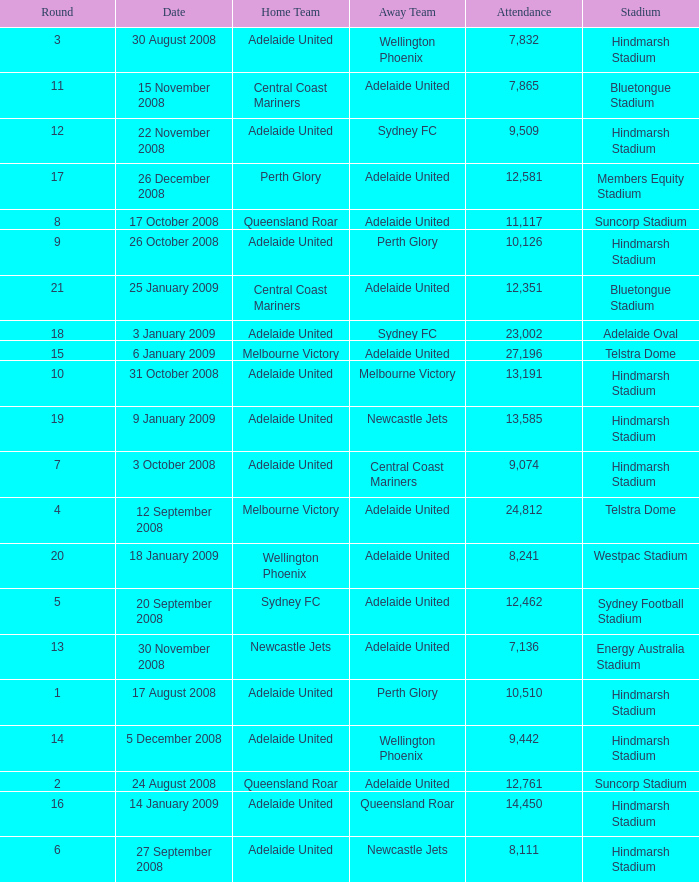What is the round when 11,117 people attended the game on 26 October 2008? 9.0. 